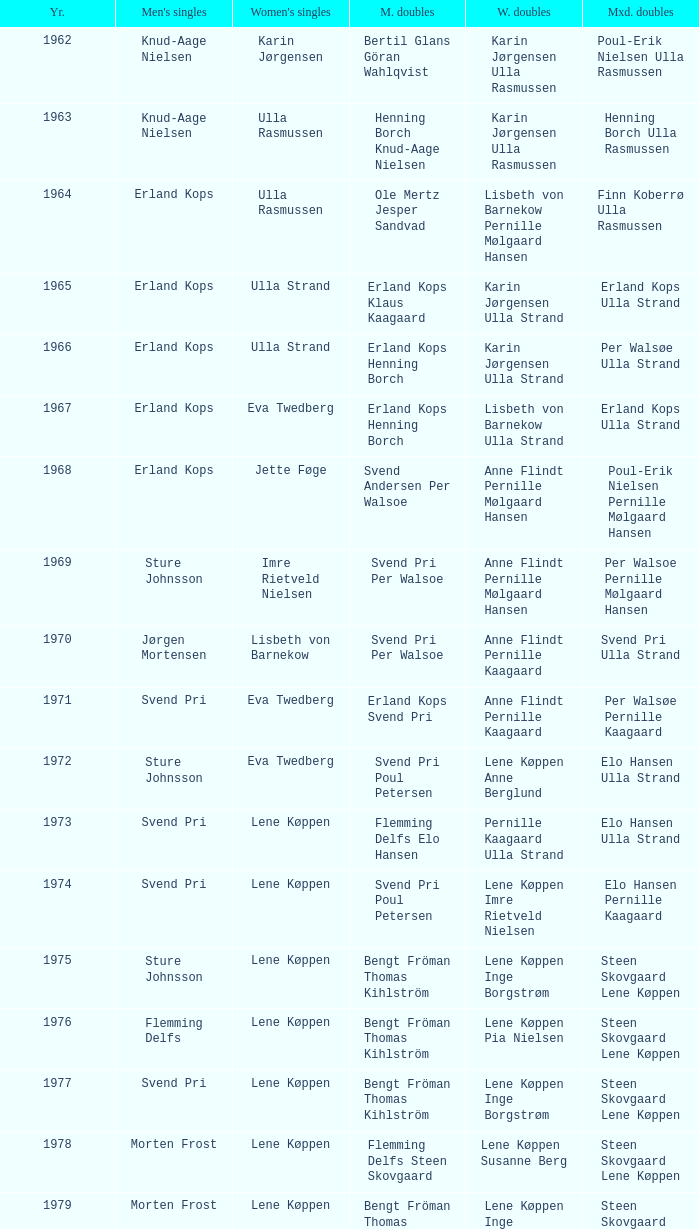Who won the men's doubles the year Pernille Nedergaard won the women's singles? Thomas Stuer-Lauridsen Max Gandrup. 